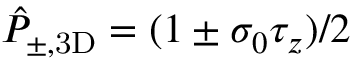<formula> <loc_0><loc_0><loc_500><loc_500>\hat { P } _ { \pm , 3 D } = ( 1 \pm \sigma _ { 0 } \tau _ { z } ) / 2</formula> 